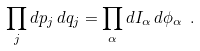Convert formula to latex. <formula><loc_0><loc_0><loc_500><loc_500>\prod _ { j } d p _ { j } \, d q _ { j } = \prod _ { \alpha } d I _ { \alpha } \, d \phi _ { \alpha } \ .</formula> 